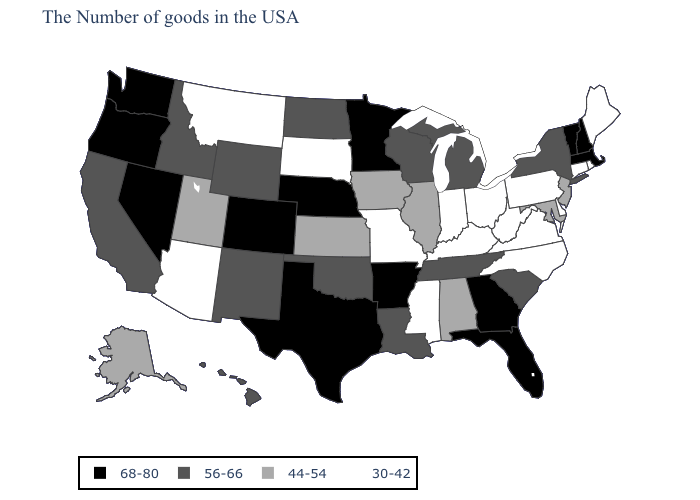Among the states that border Texas , which have the lowest value?
Short answer required. Louisiana, Oklahoma, New Mexico. What is the lowest value in states that border Ohio?
Be succinct. 30-42. Does Tennessee have a lower value than Connecticut?
Write a very short answer. No. Name the states that have a value in the range 56-66?
Give a very brief answer. New York, South Carolina, Michigan, Tennessee, Wisconsin, Louisiana, Oklahoma, North Dakota, Wyoming, New Mexico, Idaho, California, Hawaii. Does Illinois have the same value as Nebraska?
Answer briefly. No. Name the states that have a value in the range 44-54?
Keep it brief. New Jersey, Maryland, Alabama, Illinois, Iowa, Kansas, Utah, Alaska. Does Idaho have the highest value in the USA?
Short answer required. No. What is the value of Kansas?
Keep it brief. 44-54. What is the highest value in states that border New Hampshire?
Write a very short answer. 68-80. Does Colorado have the highest value in the USA?
Short answer required. Yes. Which states have the lowest value in the West?
Quick response, please. Montana, Arizona. What is the value of Missouri?
Short answer required. 30-42. What is the lowest value in the USA?
Quick response, please. 30-42. Name the states that have a value in the range 56-66?
Short answer required. New York, South Carolina, Michigan, Tennessee, Wisconsin, Louisiana, Oklahoma, North Dakota, Wyoming, New Mexico, Idaho, California, Hawaii. Name the states that have a value in the range 44-54?
Give a very brief answer. New Jersey, Maryland, Alabama, Illinois, Iowa, Kansas, Utah, Alaska. 